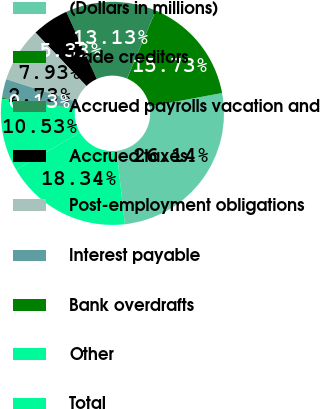Convert chart. <chart><loc_0><loc_0><loc_500><loc_500><pie_chart><fcel>(Dollars in millions)<fcel>Trade creditors<fcel>Accrued payrolls vacation and<fcel>Accrued taxes<fcel>Post-employment obligations<fcel>Interest payable<fcel>Bank overdrafts<fcel>Other<fcel>Total<nl><fcel>26.14%<fcel>15.73%<fcel>13.13%<fcel>5.33%<fcel>7.93%<fcel>2.73%<fcel>0.13%<fcel>10.53%<fcel>18.34%<nl></chart> 